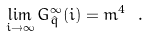Convert formula to latex. <formula><loc_0><loc_0><loc_500><loc_500>\lim _ { i \to \infty } G ^ { \infty } _ { \hat { q } } ( i ) = m ^ { 4 } \ .</formula> 